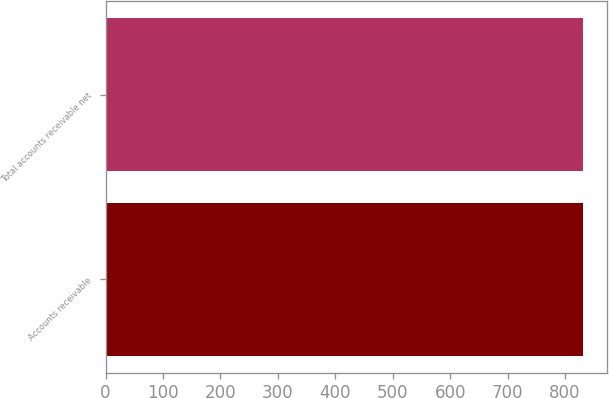Convert chart. <chart><loc_0><loc_0><loc_500><loc_500><bar_chart><fcel>Accounts receivable<fcel>Total accounts receivable net<nl><fcel>832<fcel>832.1<nl></chart> 